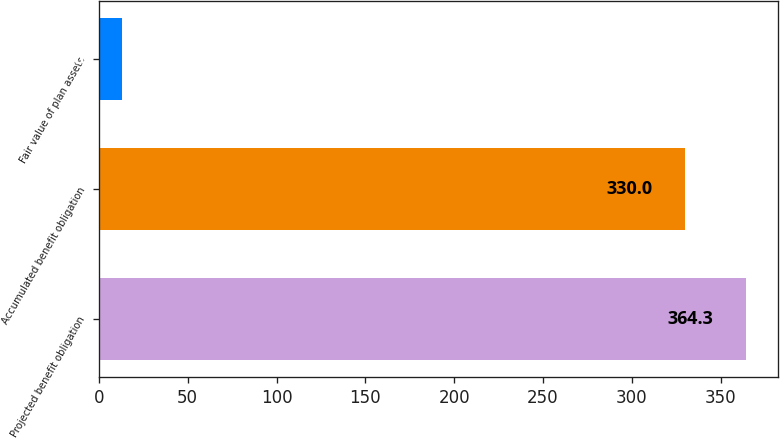Convert chart to OTSL. <chart><loc_0><loc_0><loc_500><loc_500><bar_chart><fcel>Projected benefit obligation<fcel>Accumulated benefit obligation<fcel>Fair value of plan assets<nl><fcel>364.3<fcel>330<fcel>13<nl></chart> 